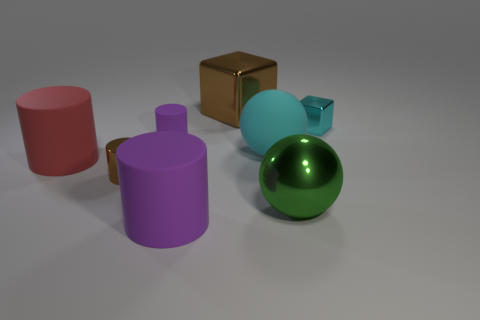Subtract all red cylinders. How many cylinders are left? 3 Add 1 metal things. How many objects exist? 9 Subtract all purple cylinders. How many cylinders are left? 2 Subtract all spheres. How many objects are left? 6 Subtract 3 cylinders. How many cylinders are left? 1 Subtract 0 yellow spheres. How many objects are left? 8 Subtract all purple cylinders. Subtract all red balls. How many cylinders are left? 2 Subtract all yellow blocks. How many brown balls are left? 0 Subtract all blocks. Subtract all small cubes. How many objects are left? 5 Add 5 large cyan balls. How many large cyan balls are left? 6 